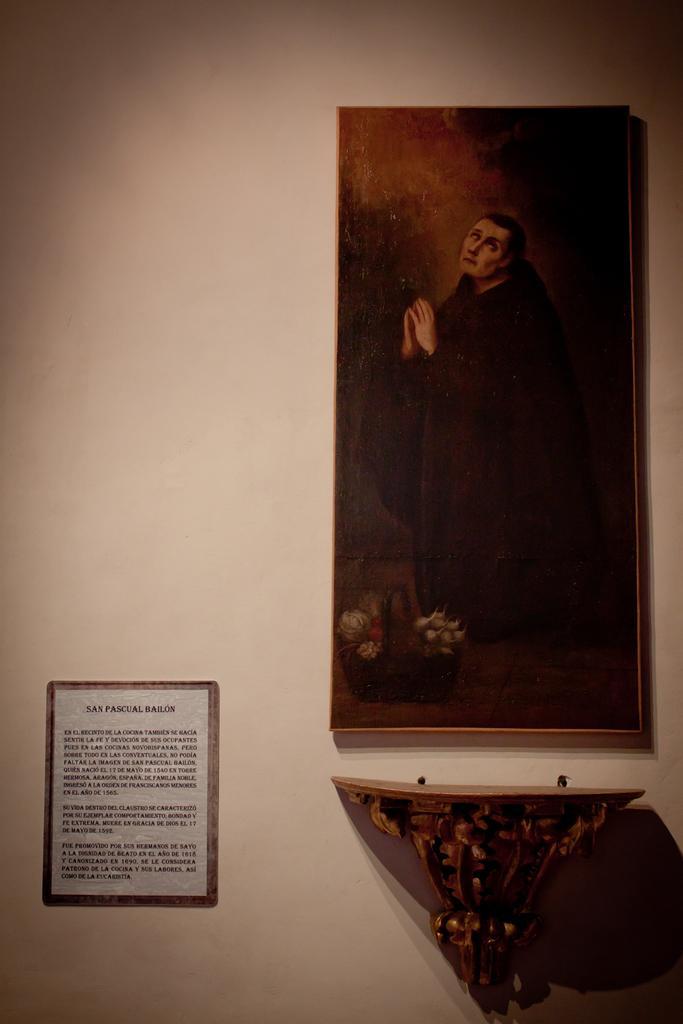Can you describe this image briefly? In this picture I can see a wall painting which is clicked in dark and there is an object which is attached to the wall just below the wall painting and besides this wall painting and left side of the image I can see a framed label stick to the wall. 